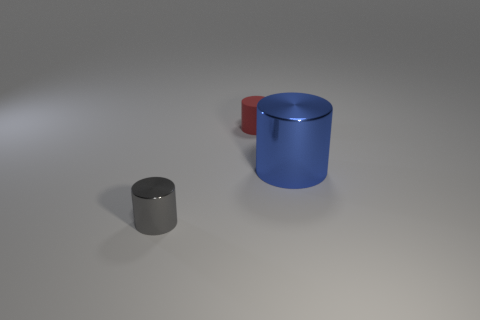What shape is the object that is made of the same material as the gray cylinder?
Ensure brevity in your answer.  Cylinder. Are there fewer red rubber cylinders in front of the gray thing than green matte cylinders?
Ensure brevity in your answer.  No. Do the large object and the red rubber object have the same shape?
Make the answer very short. Yes. What number of metal things are purple spheres or tiny gray cylinders?
Your answer should be compact. 1. Are there any blue shiny things that have the same size as the red matte object?
Offer a terse response. No. What number of red rubber objects have the same size as the red rubber cylinder?
Ensure brevity in your answer.  0. There is a metal object that is to the right of the tiny red thing; is it the same size as the object on the left side of the matte thing?
Give a very brief answer. No. How many objects are either big metal cylinders or objects left of the big object?
Provide a succinct answer. 3. The matte thing has what color?
Provide a short and direct response. Red. There is a tiny cylinder behind the shiny object that is on the left side of the thing right of the tiny red cylinder; what is its material?
Ensure brevity in your answer.  Rubber. 